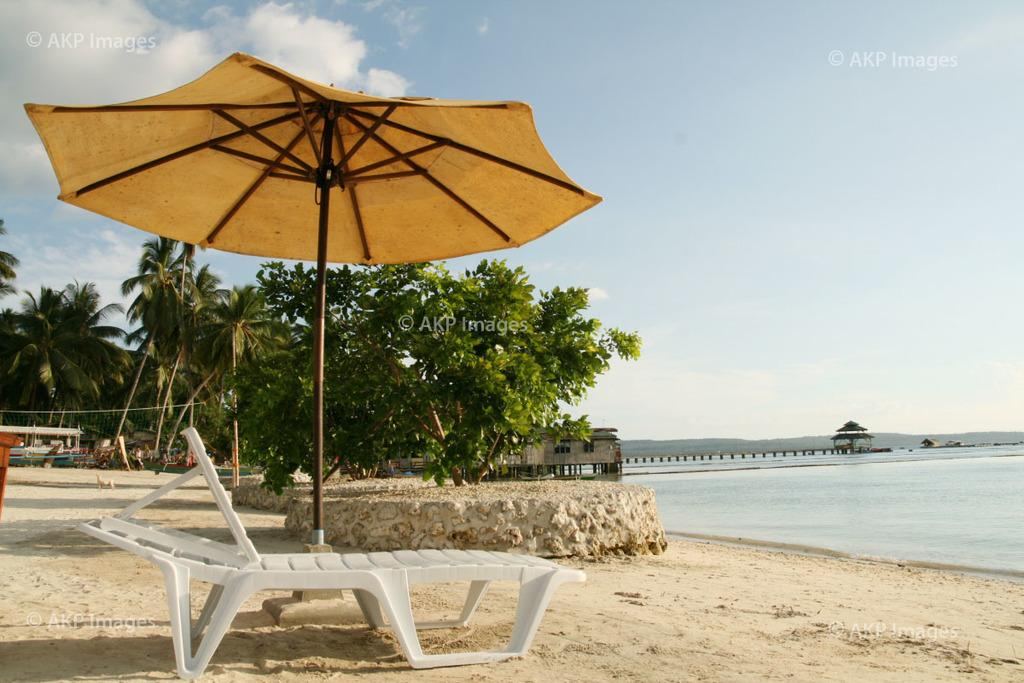What object is located in the foreground of the image? There is an umbrella in the foreground of the image. What piece of furniture is also in the foreground of the image? There is a bench in the foreground of the image. What type of vegetation can be seen in the background of the image? There are trees in the background of the image. What man-made structure is visible in the background of the image? There is a dock in the background of the image. What geographical feature might be visible in the background of the image? It appears there are mountains in the background of the image. What part of the natural environment is visible in the background of the image? The sky is visible in the background of the image. What type of pipe can be seen being played by a snail in the image? There is no pipe or snail present in the image. 